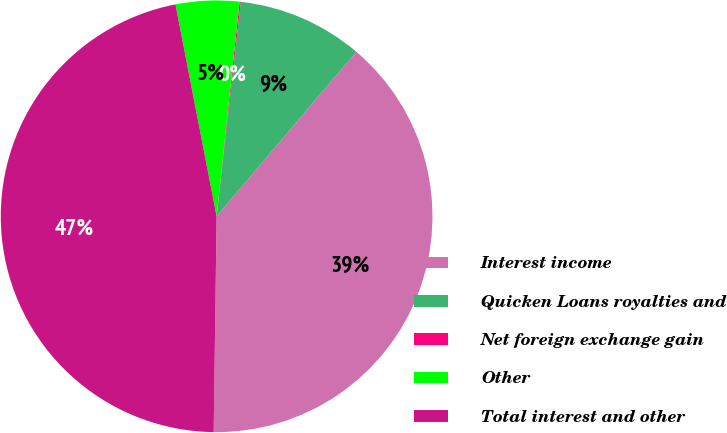Convert chart to OTSL. <chart><loc_0><loc_0><loc_500><loc_500><pie_chart><fcel>Interest income<fcel>Quicken Loans royalties and<fcel>Net foreign exchange gain<fcel>Other<fcel>Total interest and other<nl><fcel>39.01%<fcel>9.42%<fcel>0.09%<fcel>4.75%<fcel>46.73%<nl></chart> 